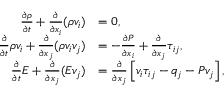<formula> <loc_0><loc_0><loc_500><loc_500>\begin{array} { r l } { \frac { \partial \rho } { \partial t } + \frac { \partial } { \partial x _ { i } } ( \rho v _ { i } ) } & { = 0 , } \\ { \frac { \partial } { \partial t } \rho v _ { i } + \frac { \partial } { \partial x _ { j } } ( \rho v _ { i } v _ { j } ) } & { = - \frac { \partial P } { \partial x _ { i } } + \frac { \partial } { \partial x _ { j } } \tau _ { i j } , } \\ { \frac { \partial } { \partial t } E + \frac { \partial } { \partial x _ { j } } ( E v _ { j } ) } & { = \frac { \partial } { \partial x _ { j } } \left [ v _ { i } \tau _ { i j } - q _ { j } - P v _ { j } \right ] , } \end{array}</formula> 